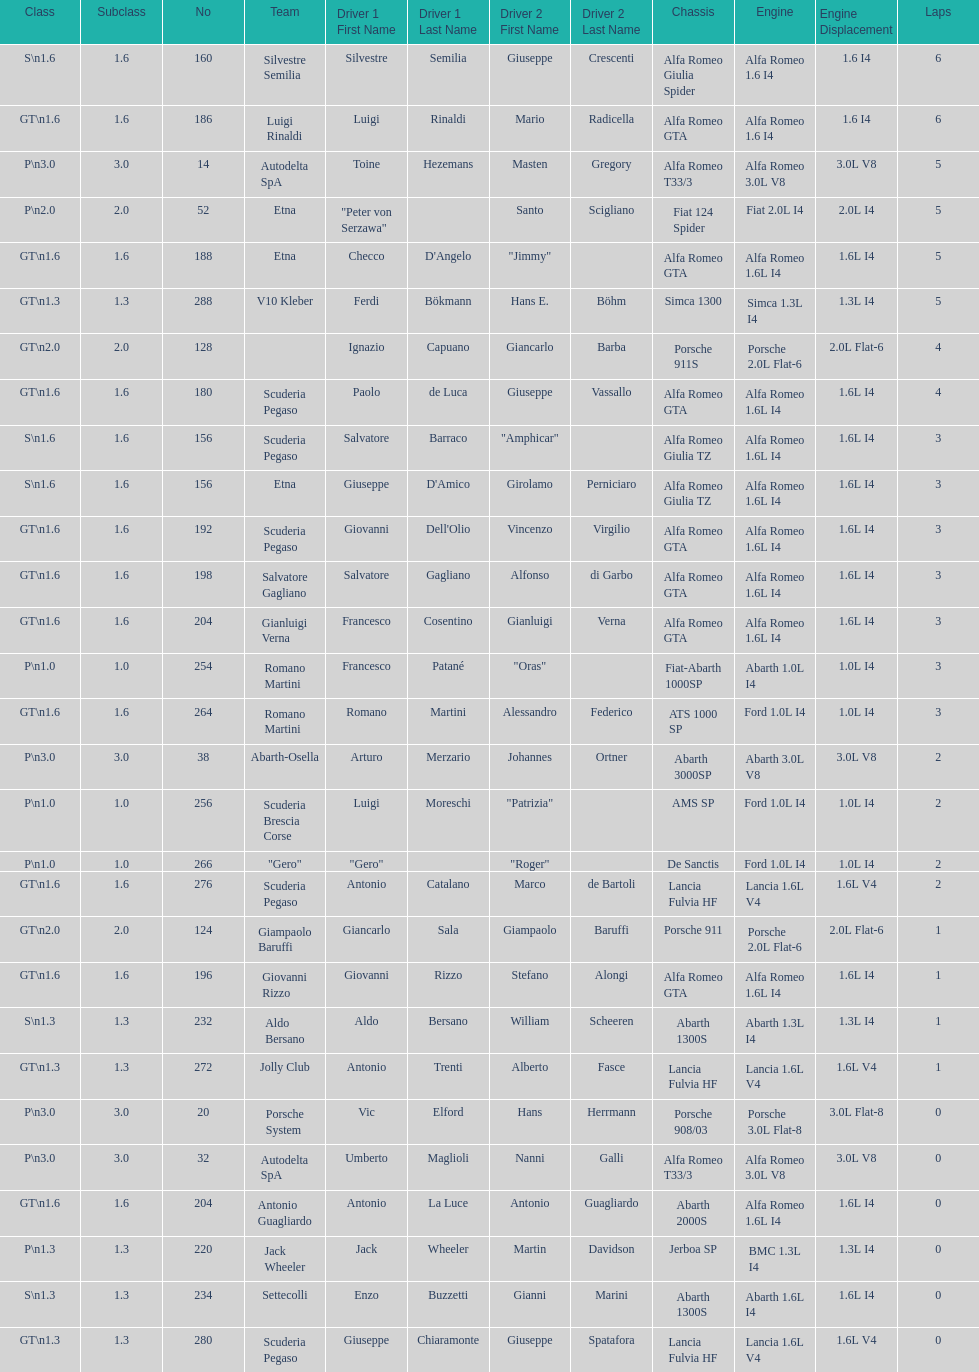What class is below s 1.6? GT 1.6. 